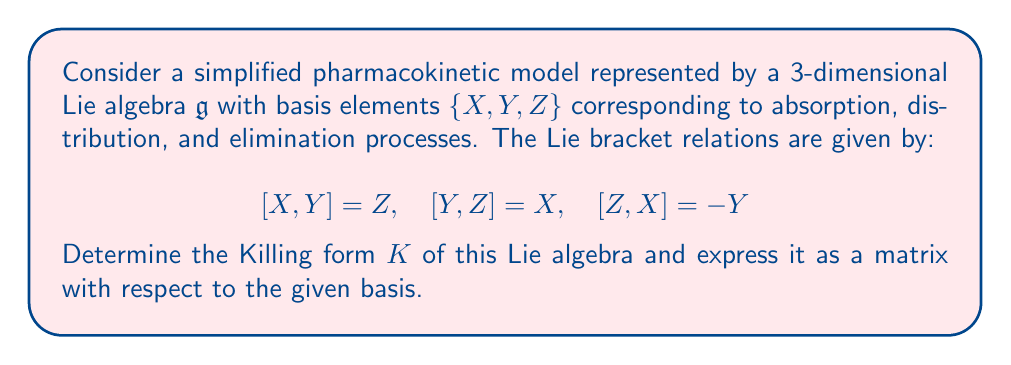Show me your answer to this math problem. To solve this problem, we'll follow these steps:

1) The Killing form $K$ is a symmetric bilinear form defined on a Lie algebra $\mathfrak{g}$. For elements $A, B \in \mathfrak{g}$, it is given by:

   $K(A,B) = \text{Tr}(\text{ad}(A) \circ \text{ad}(B))$

   where $\text{ad}(A)$ is the adjoint representation of $A$ and $\text{Tr}$ denotes the trace.

2) We need to calculate $\text{ad}(X)$, $\text{ad}(Y)$, and $\text{ad}(Z)$ with respect to the given basis:

   $\text{ad}(X) = \begin{pmatrix} 0 & 0 & -1 \\ 0 & 0 & 0 \\ 0 & 1 & 0 \end{pmatrix}$

   $\text{ad}(Y) = \begin{pmatrix} 0 & 0 & 0 \\ 0 & 0 & 1 \\ -1 & 0 & 0 \end{pmatrix}$

   $\text{ad}(Z) = \begin{pmatrix} 0 & -1 & 0 \\ 1 & 0 & 0 \\ 0 & 0 & 0 \end{pmatrix}$

3) Now, we calculate the entries of the Killing form matrix:

   $K(X,X) = \text{Tr}(\text{ad}(X) \circ \text{ad}(X)) = -2$
   $K(Y,Y) = \text{Tr}(\text{ad}(Y) \circ \text{ad}(Y)) = -2$
   $K(Z,Z) = \text{Tr}(\text{ad}(Z) \circ \text{ad}(Z)) = -2$

   $K(X,Y) = K(Y,X) = \text{Tr}(\text{ad}(X) \circ \text{ad}(Y)) = 0$
   $K(X,Z) = K(Z,X) = \text{Tr}(\text{ad}(X) \circ \text{ad}(Z)) = 0$
   $K(Y,Z) = K(Z,Y) = \text{Tr}(\text{ad}(Y) \circ \text{ad}(Z)) = 0$

4) We can now express the Killing form as a matrix:

   $K = \begin{pmatrix} -2 & 0 & 0 \\ 0 & -2 & 0 \\ 0 & 0 & -2 \end{pmatrix}$

This Killing form matrix represents the "inner product" structure of the Lie algebra, which in this pharmacokinetic context, describes how the absorption, distribution, and elimination processes interact in terms of their infinitesimal generators.
Answer: The Killing form $K$ of the given Lie algebra, with respect to the basis $\{X, Y, Z\}$, is:

$$K = \begin{pmatrix} -2 & 0 & 0 \\ 0 & -2 & 0 \\ 0 & 0 & -2 \end{pmatrix}$$ 